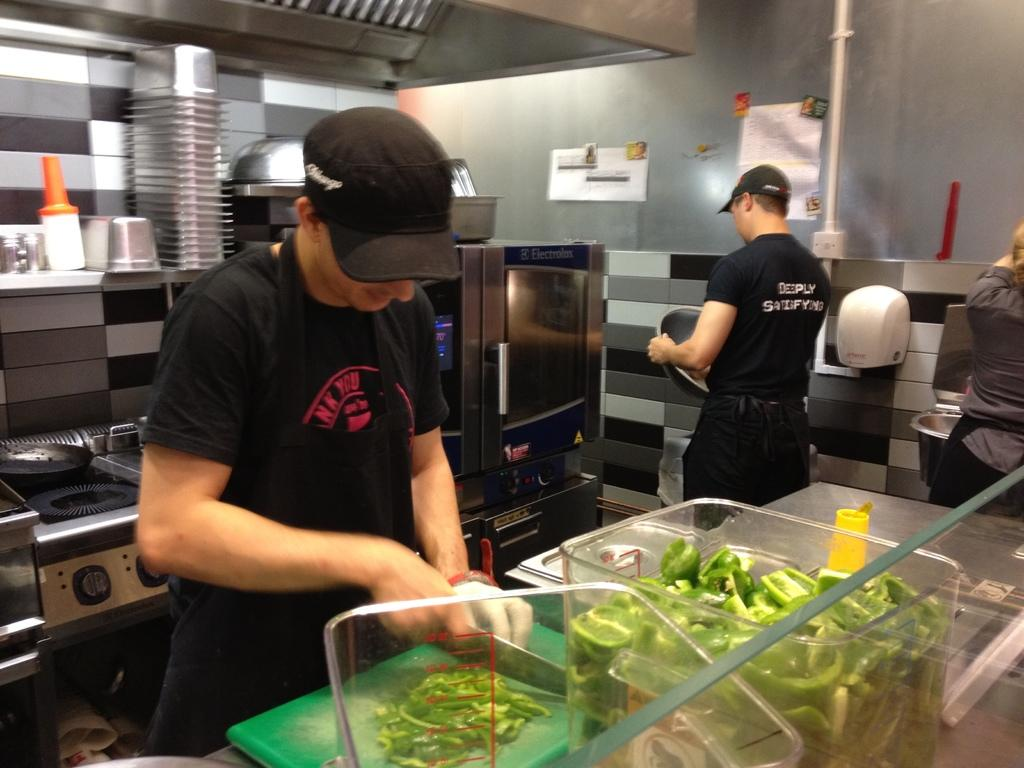<image>
Write a terse but informative summary of the picture. people inside a restaurant kitchen wearing shirts reading Deeply Satisfying 